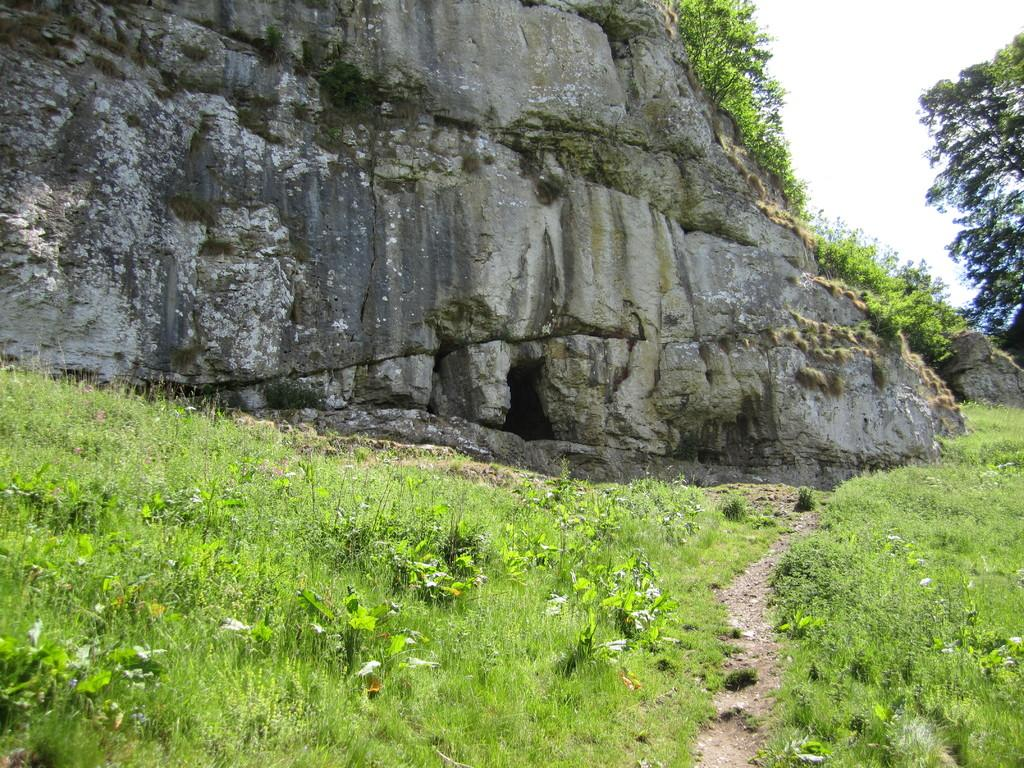What type of geological formation is present in the image? There is a rock hill in the image. What can be seen around the rock hill? There are many plants and grass around the hill. Can you describe the tree in the image? There is a tree on the right side of the image. How many icicles are hanging from the tree in the image? There are no icicles present in the image, as it is not a cold environment where icicles would form. 